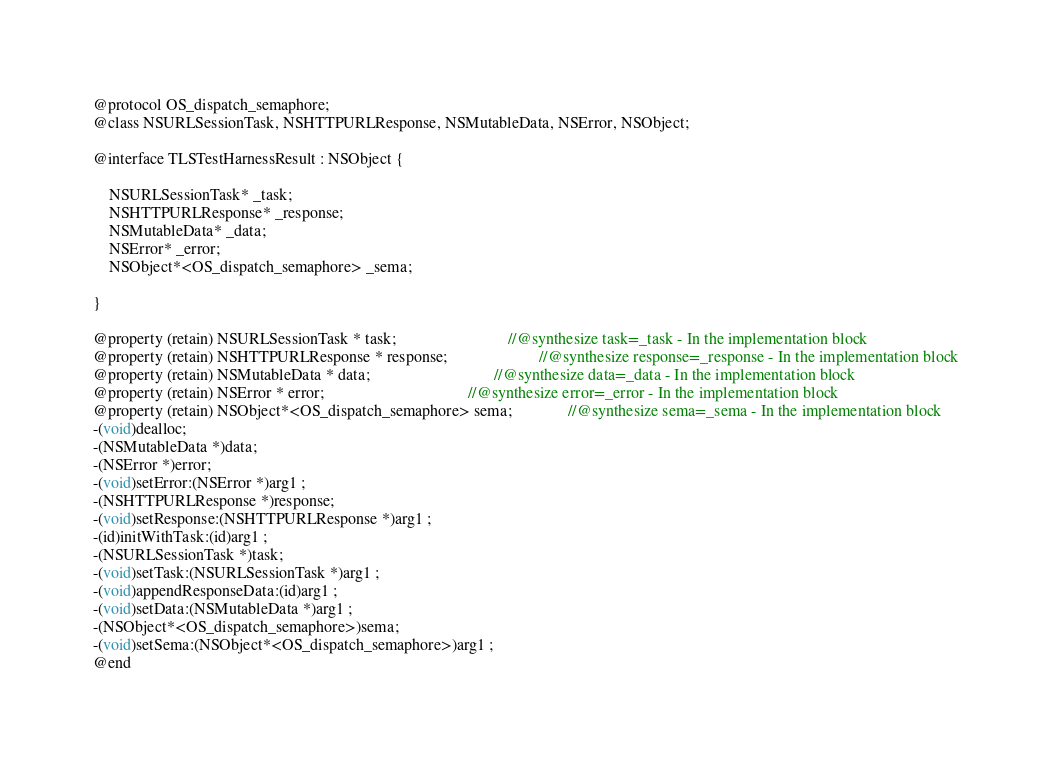Convert code to text. <code><loc_0><loc_0><loc_500><loc_500><_C_>
@protocol OS_dispatch_semaphore;
@class NSURLSessionTask, NSHTTPURLResponse, NSMutableData, NSError, NSObject;

@interface TLSTestHarnessResult : NSObject {

	NSURLSessionTask* _task;
	NSHTTPURLResponse* _response;
	NSMutableData* _data;
	NSError* _error;
	NSObject*<OS_dispatch_semaphore> _sema;

}

@property (retain) NSURLSessionTask * task;                            //@synthesize task=_task - In the implementation block
@property (retain) NSHTTPURLResponse * response;                       //@synthesize response=_response - In the implementation block
@property (retain) NSMutableData * data;                               //@synthesize data=_data - In the implementation block
@property (retain) NSError * error;                                    //@synthesize error=_error - In the implementation block
@property (retain) NSObject*<OS_dispatch_semaphore> sema;              //@synthesize sema=_sema - In the implementation block
-(void)dealloc;
-(NSMutableData *)data;
-(NSError *)error;
-(void)setError:(NSError *)arg1 ;
-(NSHTTPURLResponse *)response;
-(void)setResponse:(NSHTTPURLResponse *)arg1 ;
-(id)initWithTask:(id)arg1 ;
-(NSURLSessionTask *)task;
-(void)setTask:(NSURLSessionTask *)arg1 ;
-(void)appendResponseData:(id)arg1 ;
-(void)setData:(NSMutableData *)arg1 ;
-(NSObject*<OS_dispatch_semaphore>)sema;
-(void)setSema:(NSObject*<OS_dispatch_semaphore>)arg1 ;
@end

</code> 